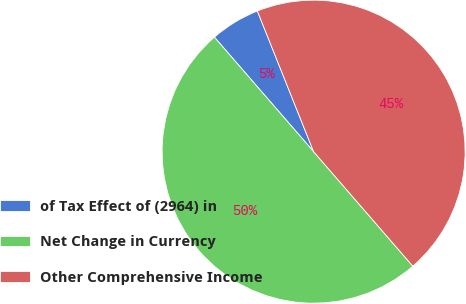Convert chart. <chart><loc_0><loc_0><loc_500><loc_500><pie_chart><fcel>of Tax Effect of (2964) in<fcel>Net Change in Currency<fcel>Other Comprehensive Income<nl><fcel>5.31%<fcel>50.0%<fcel>44.69%<nl></chart> 